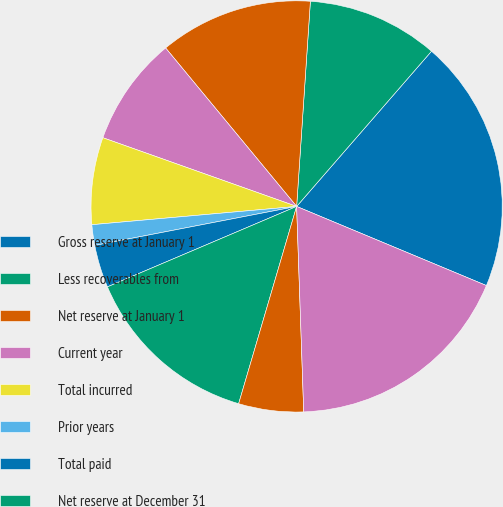Convert chart to OTSL. <chart><loc_0><loc_0><loc_500><loc_500><pie_chart><fcel>Gross reserve at January 1<fcel>Less recoverables from<fcel>Net reserve at January 1<fcel>Current year<fcel>Total incurred<fcel>Prior years<fcel>Total paid<fcel>Net reserve at December 31<fcel>Plus recoverables from<fcel>Gross reserve at December 31<nl><fcel>19.9%<fcel>10.32%<fcel>12.06%<fcel>8.58%<fcel>6.84%<fcel>1.62%<fcel>3.36%<fcel>14.05%<fcel>5.1%<fcel>18.16%<nl></chart> 